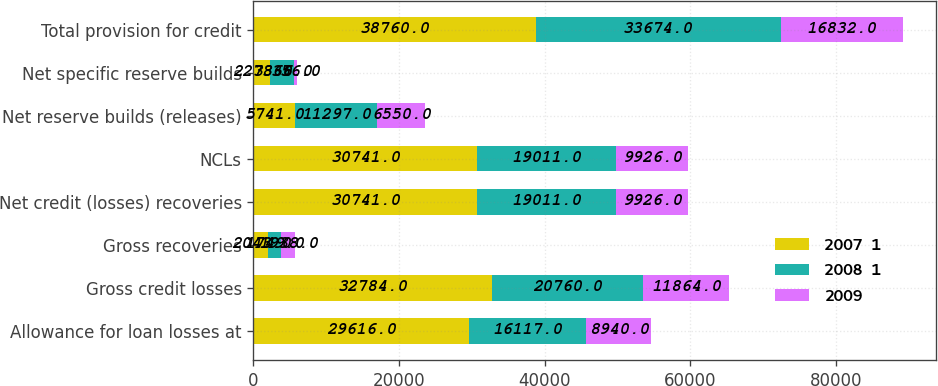Convert chart. <chart><loc_0><loc_0><loc_500><loc_500><stacked_bar_chart><ecel><fcel>Allowance for loan losses at<fcel>Gross credit losses<fcel>Gross recoveries<fcel>Net credit (losses) recoveries<fcel>NCLs<fcel>Net reserve builds (releases)<fcel>Net specific reserve builds<fcel>Total provision for credit<nl><fcel>2007  1<fcel>29616<fcel>32784<fcel>2043<fcel>30741<fcel>30741<fcel>5741<fcel>2278<fcel>38760<nl><fcel>2008  1<fcel>16117<fcel>20760<fcel>1749<fcel>19011<fcel>19011<fcel>11297<fcel>3366<fcel>33674<nl><fcel>2009<fcel>8940<fcel>11864<fcel>1938<fcel>9926<fcel>9926<fcel>6550<fcel>356<fcel>16832<nl></chart> 